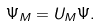Convert formula to latex. <formula><loc_0><loc_0><loc_500><loc_500>\Psi _ { M } = { U } _ { M } \Psi .</formula> 